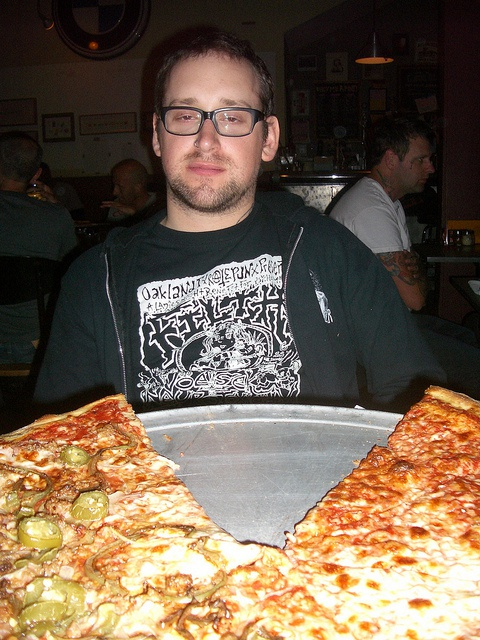Describe the objects in this image and their specific colors. I can see people in black, white, tan, and gray tones, pizza in black, beige, orange, khaki, and red tones, people in black, gray, and maroon tones, chair in black tones, and people in black, maroon, and navy tones in this image. 